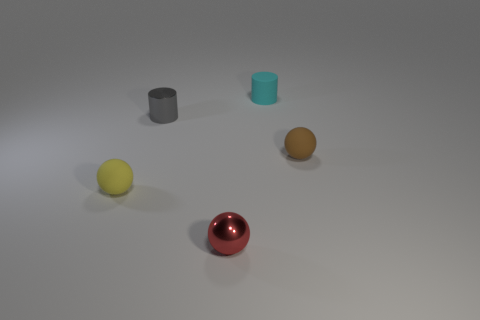Add 4 tiny gray shiny objects. How many objects exist? 9 Subtract all cylinders. How many objects are left? 3 Add 1 tiny red shiny spheres. How many tiny red shiny spheres are left? 2 Add 5 gray objects. How many gray objects exist? 6 Subtract 0 purple cubes. How many objects are left? 5 Subtract all tiny metallic objects. Subtract all brown objects. How many objects are left? 2 